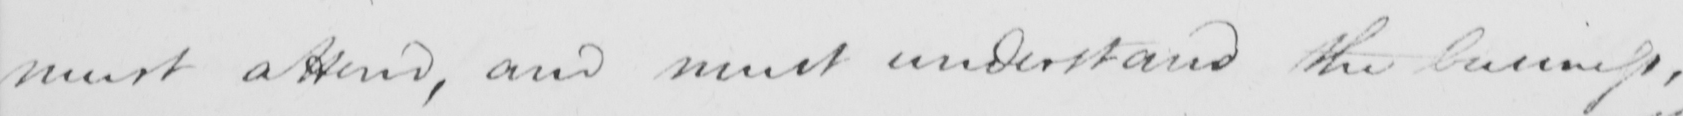What text is written in this handwritten line? must attend , and must understand the business , 